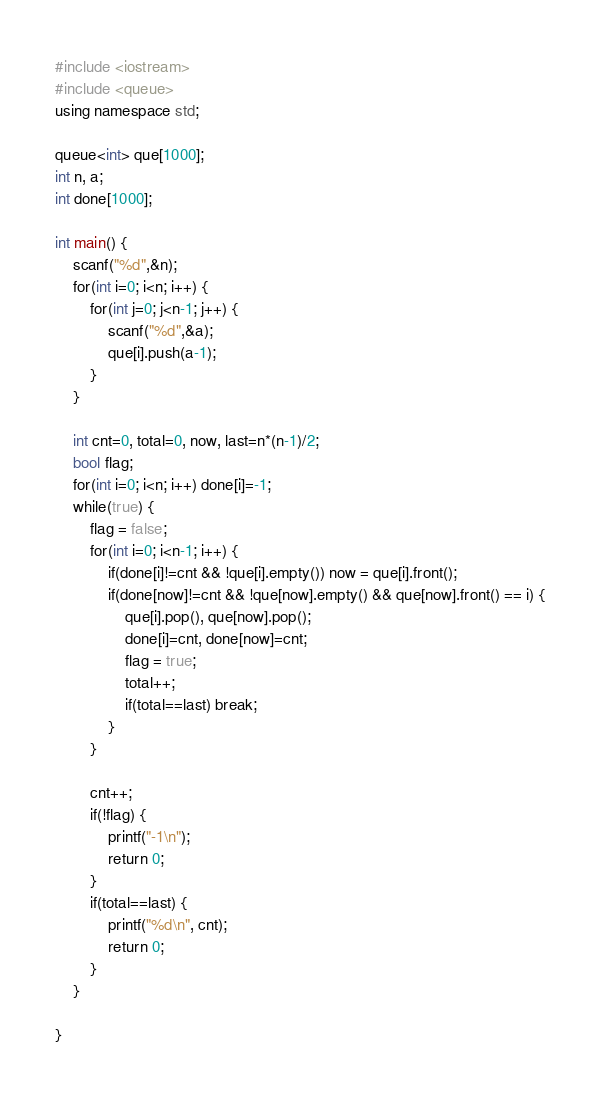<code> <loc_0><loc_0><loc_500><loc_500><_C++_>#include <iostream>
#include <queue>
using namespace std;

queue<int> que[1000];
int n, a;
int done[1000];

int main() {
    scanf("%d",&n);
    for(int i=0; i<n; i++) {
        for(int j=0; j<n-1; j++) {
            scanf("%d",&a);
            que[i].push(a-1);
        }
    }

    int cnt=0, total=0, now, last=n*(n-1)/2;
    bool flag;
    for(int i=0; i<n; i++) done[i]=-1;
    while(true) {
        flag = false;
        for(int i=0; i<n-1; i++) {
            if(done[i]!=cnt && !que[i].empty()) now = que[i].front();
            if(done[now]!=cnt && !que[now].empty() && que[now].front() == i) {
                que[i].pop(), que[now].pop();
                done[i]=cnt, done[now]=cnt;
                flag = true;
                total++;
                if(total==last) break;
            }
        }

        cnt++;
        if(!flag) {
            printf("-1\n");
            return 0;
        }
        if(total==last) {
            printf("%d\n", cnt);
            return 0;
        }
    }

}
</code> 